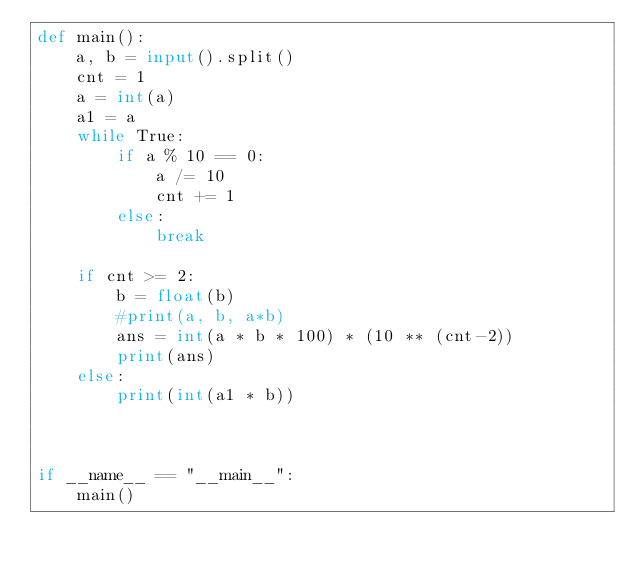<code> <loc_0><loc_0><loc_500><loc_500><_Python_>def main():
    a, b = input().split()
    cnt = 1
    a = int(a)
    a1 = a
    while True:
        if a % 10 == 0:
            a /= 10
            cnt += 1
        else:
            break

    if cnt >= 2:
        b = float(b)
        #print(a, b, a*b)
        ans = int(a * b * 100) * (10 ** (cnt-2))
        print(ans)
    else:
        print(int(a1 * b))



if __name__ == "__main__":
    main()
</code> 